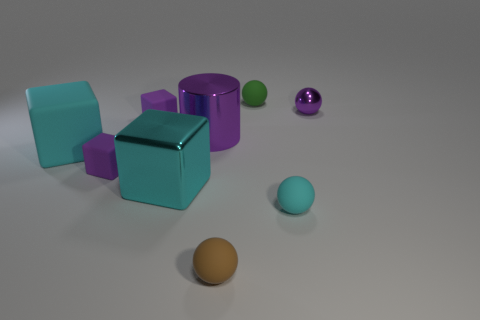Subtract all cyan spheres. How many spheres are left? 3 Subtract all cyan spheres. How many spheres are left? 3 Subtract all gray balls. Subtract all gray blocks. How many balls are left? 4 Subtract all blocks. How many objects are left? 5 Add 5 purple rubber cubes. How many purple rubber cubes exist? 7 Subtract 0 blue cylinders. How many objects are left? 9 Subtract all purple blocks. Subtract all brown rubber spheres. How many objects are left? 6 Add 3 large matte things. How many large matte things are left? 4 